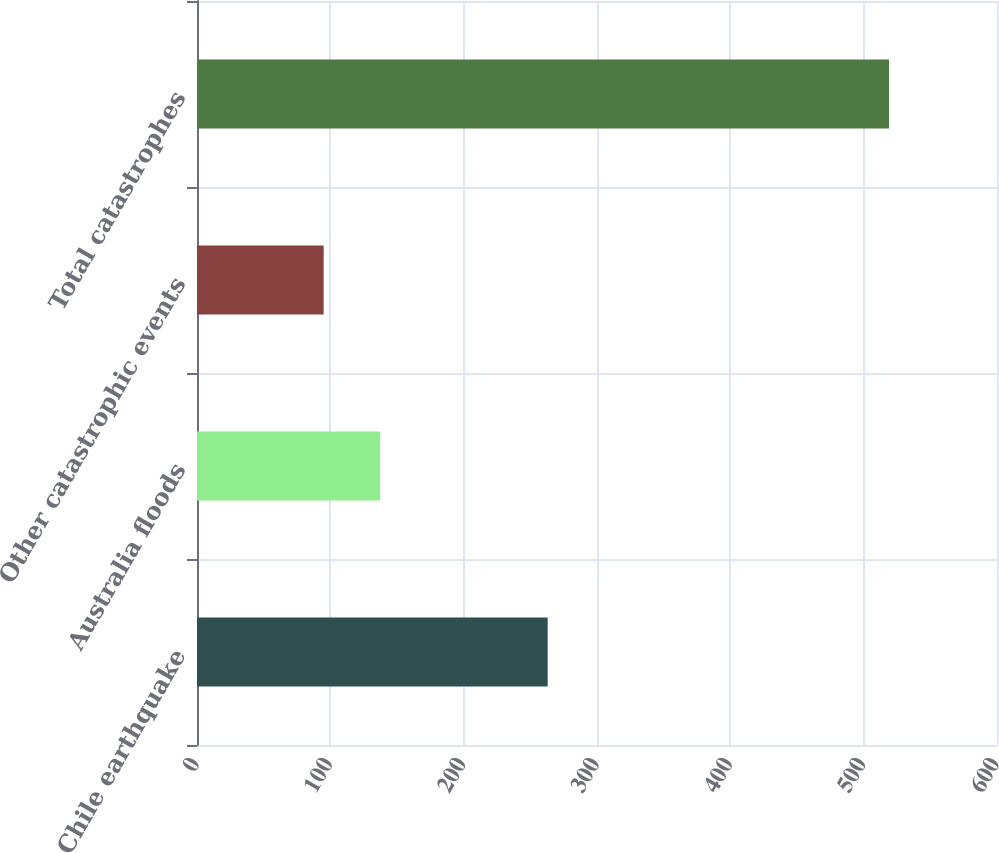Convert chart to OTSL. <chart><loc_0><loc_0><loc_500><loc_500><bar_chart><fcel>Chile earthquake<fcel>Australia floods<fcel>Other catastrophic events<fcel>Total catastrophes<nl><fcel>263<fcel>137.4<fcel>95<fcel>519<nl></chart> 